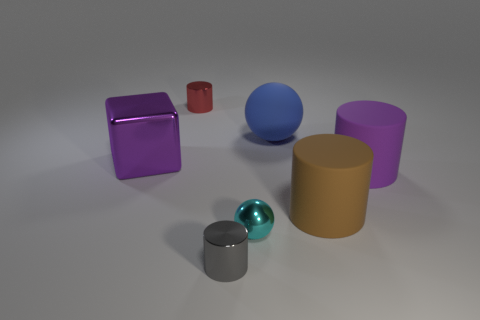Is there a big rubber object of the same color as the big metallic thing?
Offer a terse response. Yes. There is a thing that is in front of the tiny cyan object; is it the same shape as the brown object?
Offer a terse response. Yes. How many cyan objects are the same size as the purple cylinder?
Offer a very short reply. 0. How many big purple objects are to the left of the cylinder that is in front of the tiny shiny ball?
Provide a short and direct response. 1. Is the purple object in front of the shiny block made of the same material as the large brown cylinder?
Provide a short and direct response. Yes. Is the material of the big purple thing left of the big blue matte thing the same as the sphere that is on the right side of the small cyan object?
Give a very brief answer. No. Are there more small shiny cylinders behind the big blue thing than large gray rubber blocks?
Your answer should be compact. Yes. What color is the metallic cylinder that is in front of the big purple thing that is to the left of the big brown cylinder?
Provide a short and direct response. Gray. What is the shape of the gray thing that is the same size as the red thing?
Your answer should be compact. Cylinder. What shape is the large rubber thing that is the same color as the shiny block?
Your answer should be compact. Cylinder. 